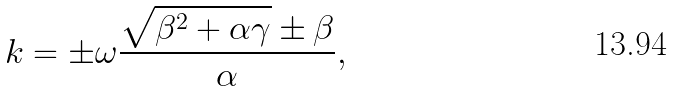<formula> <loc_0><loc_0><loc_500><loc_500>k = \pm \omega \frac { \sqrt { \beta ^ { 2 } + \alpha \gamma } \pm \beta } { \alpha } ,</formula> 